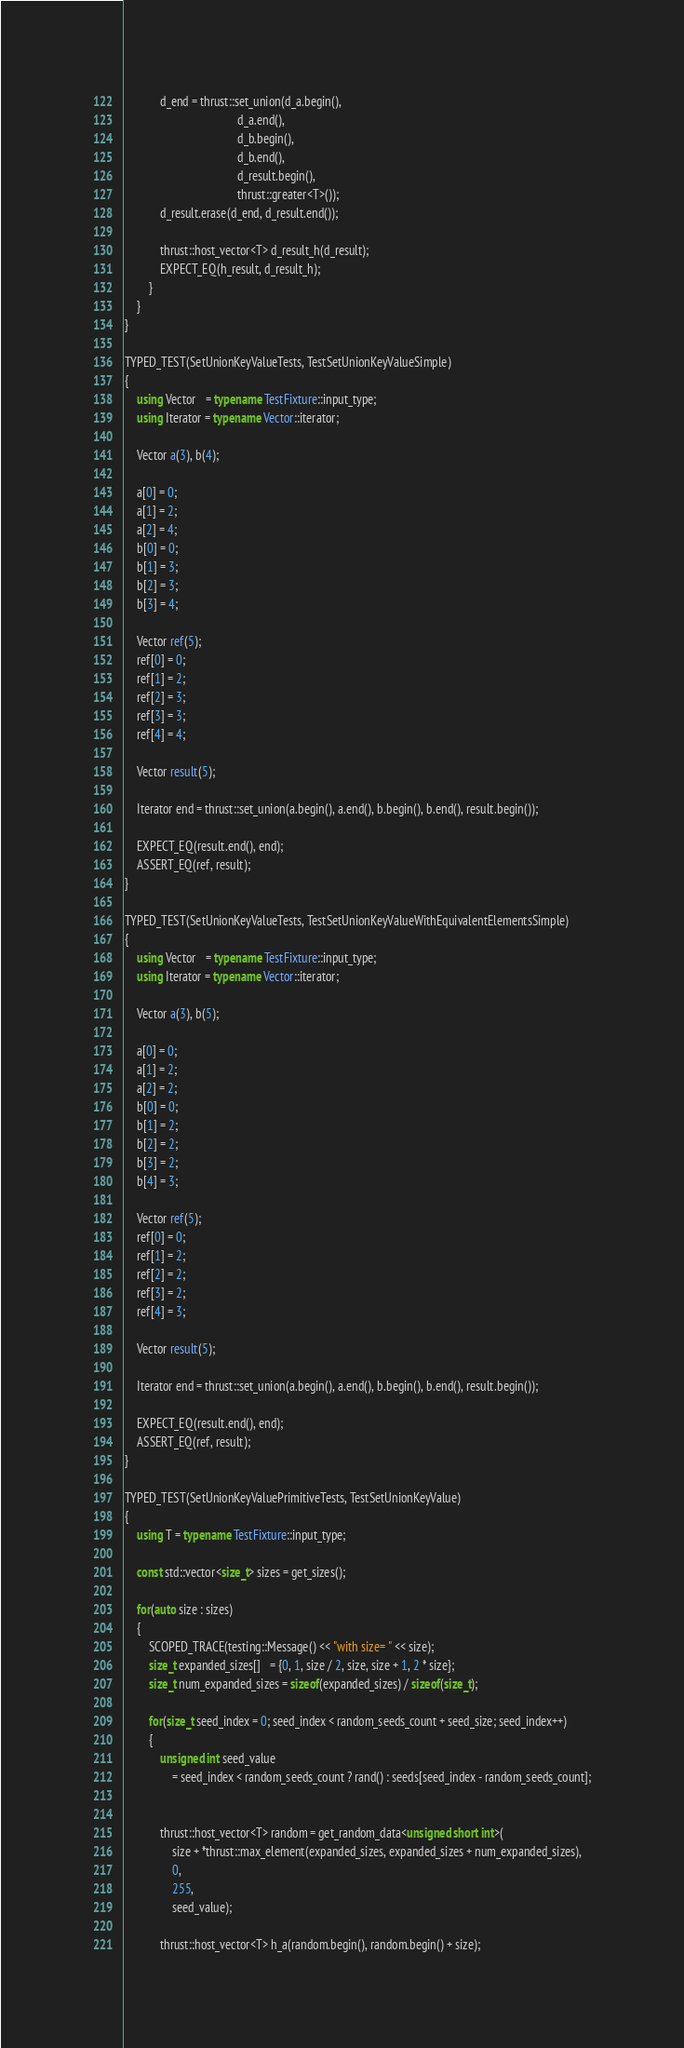Convert code to text. <code><loc_0><loc_0><loc_500><loc_500><_C++_>
            d_end = thrust::set_union(d_a.begin(),
                                      d_a.end(),
                                      d_b.begin(),
                                      d_b.end(),
                                      d_result.begin(),
                                      thrust::greater<T>());
            d_result.erase(d_end, d_result.end());

            thrust::host_vector<T> d_result_h(d_result);
            EXPECT_EQ(h_result, d_result_h);
        }
    }
}

TYPED_TEST(SetUnionKeyValueTests, TestSetUnionKeyValueSimple)
{
    using Vector   = typename TestFixture::input_type;
    using Iterator = typename Vector::iterator;

    Vector a(3), b(4);

    a[0] = 0;
    a[1] = 2;
    a[2] = 4;
    b[0] = 0;
    b[1] = 3;
    b[2] = 3;
    b[3] = 4;

    Vector ref(5);
    ref[0] = 0;
    ref[1] = 2;
    ref[2] = 3;
    ref[3] = 3;
    ref[4] = 4;

    Vector result(5);

    Iterator end = thrust::set_union(a.begin(), a.end(), b.begin(), b.end(), result.begin());

    EXPECT_EQ(result.end(), end);
    ASSERT_EQ(ref, result);
}

TYPED_TEST(SetUnionKeyValueTests, TestSetUnionKeyValueWithEquivalentElementsSimple)
{
    using Vector   = typename TestFixture::input_type;
    using Iterator = typename Vector::iterator;

    Vector a(3), b(5);

    a[0] = 0;
    a[1] = 2;
    a[2] = 2;
    b[0] = 0;
    b[1] = 2;
    b[2] = 2;
    b[3] = 2;
    b[4] = 3;

    Vector ref(5);
    ref[0] = 0;
    ref[1] = 2;
    ref[2] = 2;
    ref[3] = 2;
    ref[4] = 3;

    Vector result(5);

    Iterator end = thrust::set_union(a.begin(), a.end(), b.begin(), b.end(), result.begin());

    EXPECT_EQ(result.end(), end);
    ASSERT_EQ(ref, result);
}

TYPED_TEST(SetUnionKeyValuePrimitiveTests, TestSetUnionKeyValue)
{
    using T = typename TestFixture::input_type;

    const std::vector<size_t> sizes = get_sizes();

    for(auto size : sizes)
    {
        SCOPED_TRACE(testing::Message() << "with size= " << size);
        size_t expanded_sizes[]   = {0, 1, size / 2, size, size + 1, 2 * size};
        size_t num_expanded_sizes = sizeof(expanded_sizes) / sizeof(size_t);

        for(size_t seed_index = 0; seed_index < random_seeds_count + seed_size; seed_index++)
        {
            unsigned int seed_value
                = seed_index < random_seeds_count ? rand() : seeds[seed_index - random_seeds_count];


            thrust::host_vector<T> random = get_random_data<unsigned short int>(
                size + *thrust::max_element(expanded_sizes, expanded_sizes + num_expanded_sizes),
                0,
                255,
                seed_value);

            thrust::host_vector<T> h_a(random.begin(), random.begin() + size);</code> 